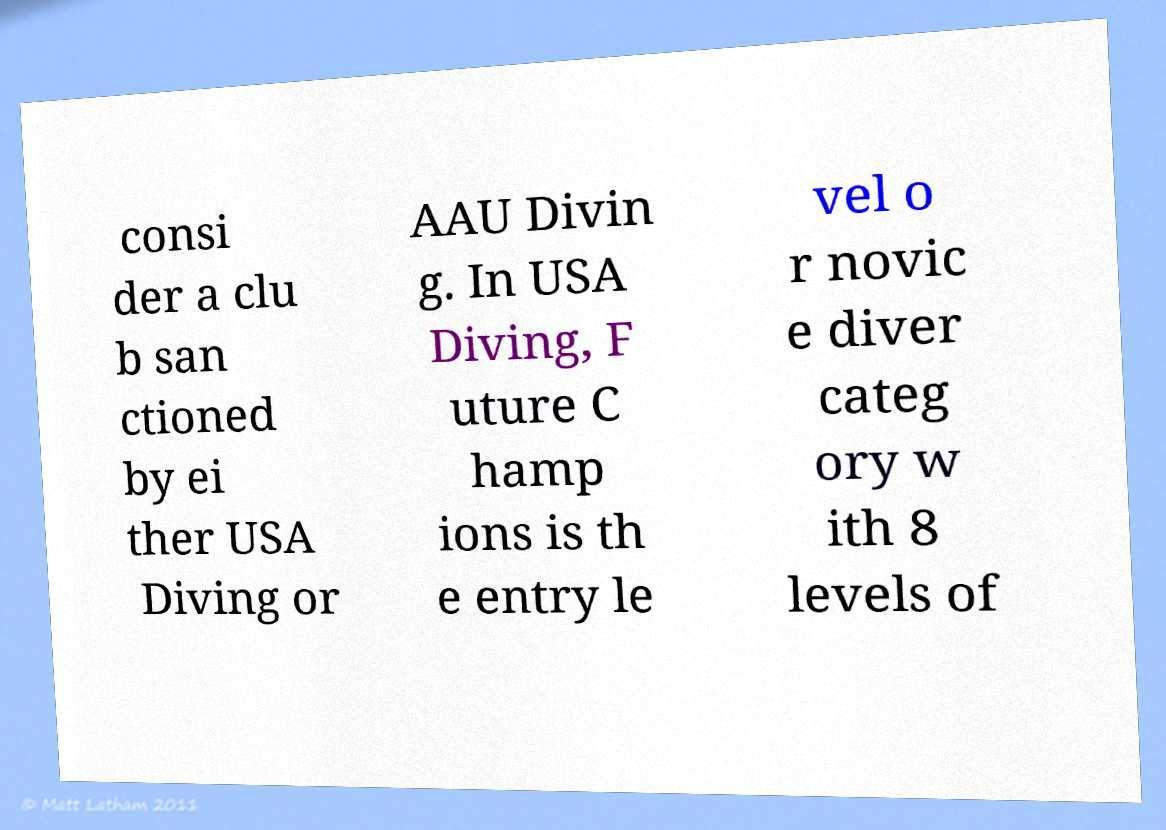Could you extract and type out the text from this image? consi der a clu b san ctioned by ei ther USA Diving or AAU Divin g. In USA Diving, F uture C hamp ions is th e entry le vel o r novic e diver categ ory w ith 8 levels of 